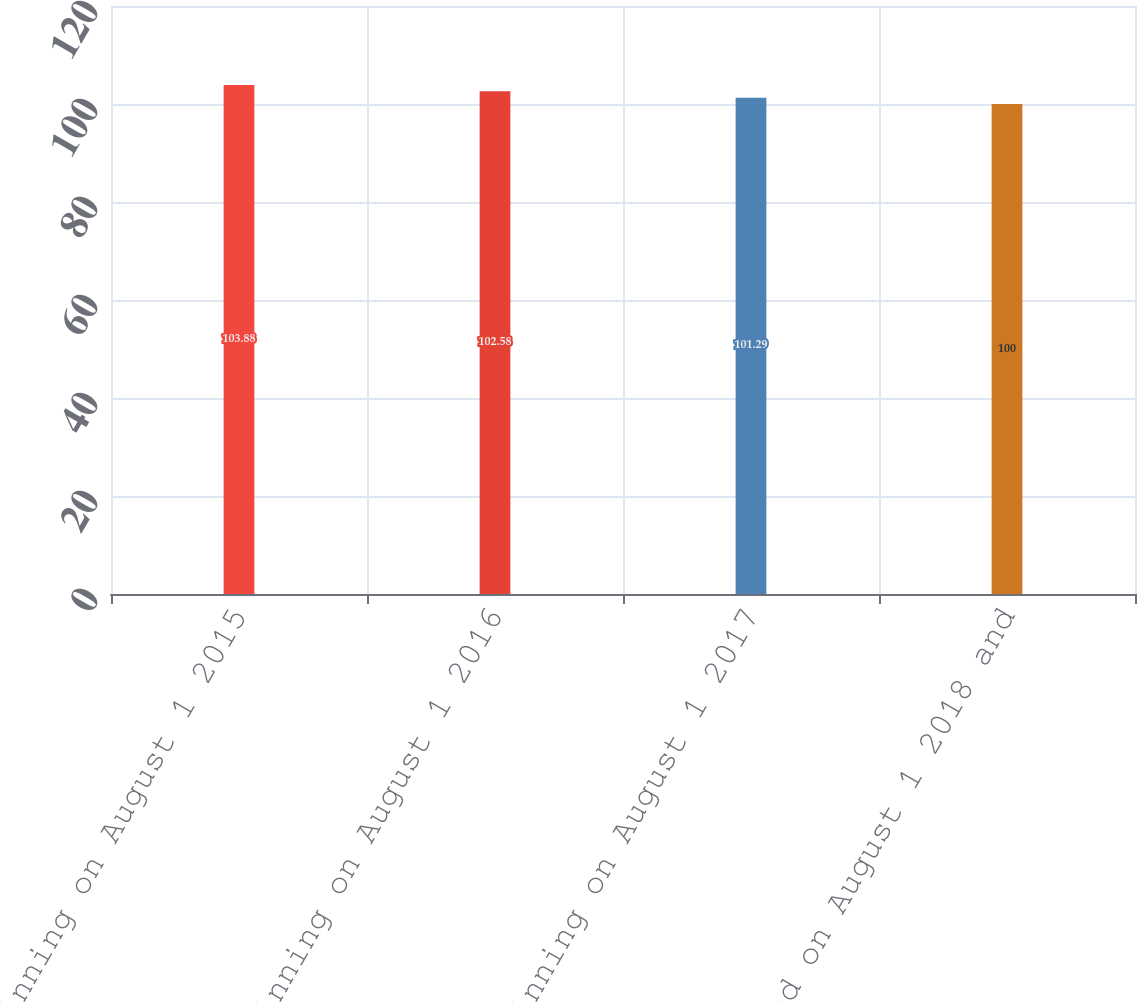Convert chart. <chart><loc_0><loc_0><loc_500><loc_500><bar_chart><fcel>Beginning on August 1 2015<fcel>Beginning on August 1 2016<fcel>Beginning on August 1 2017<fcel>and on August 1 2018 and<nl><fcel>103.88<fcel>102.58<fcel>101.29<fcel>100<nl></chart> 